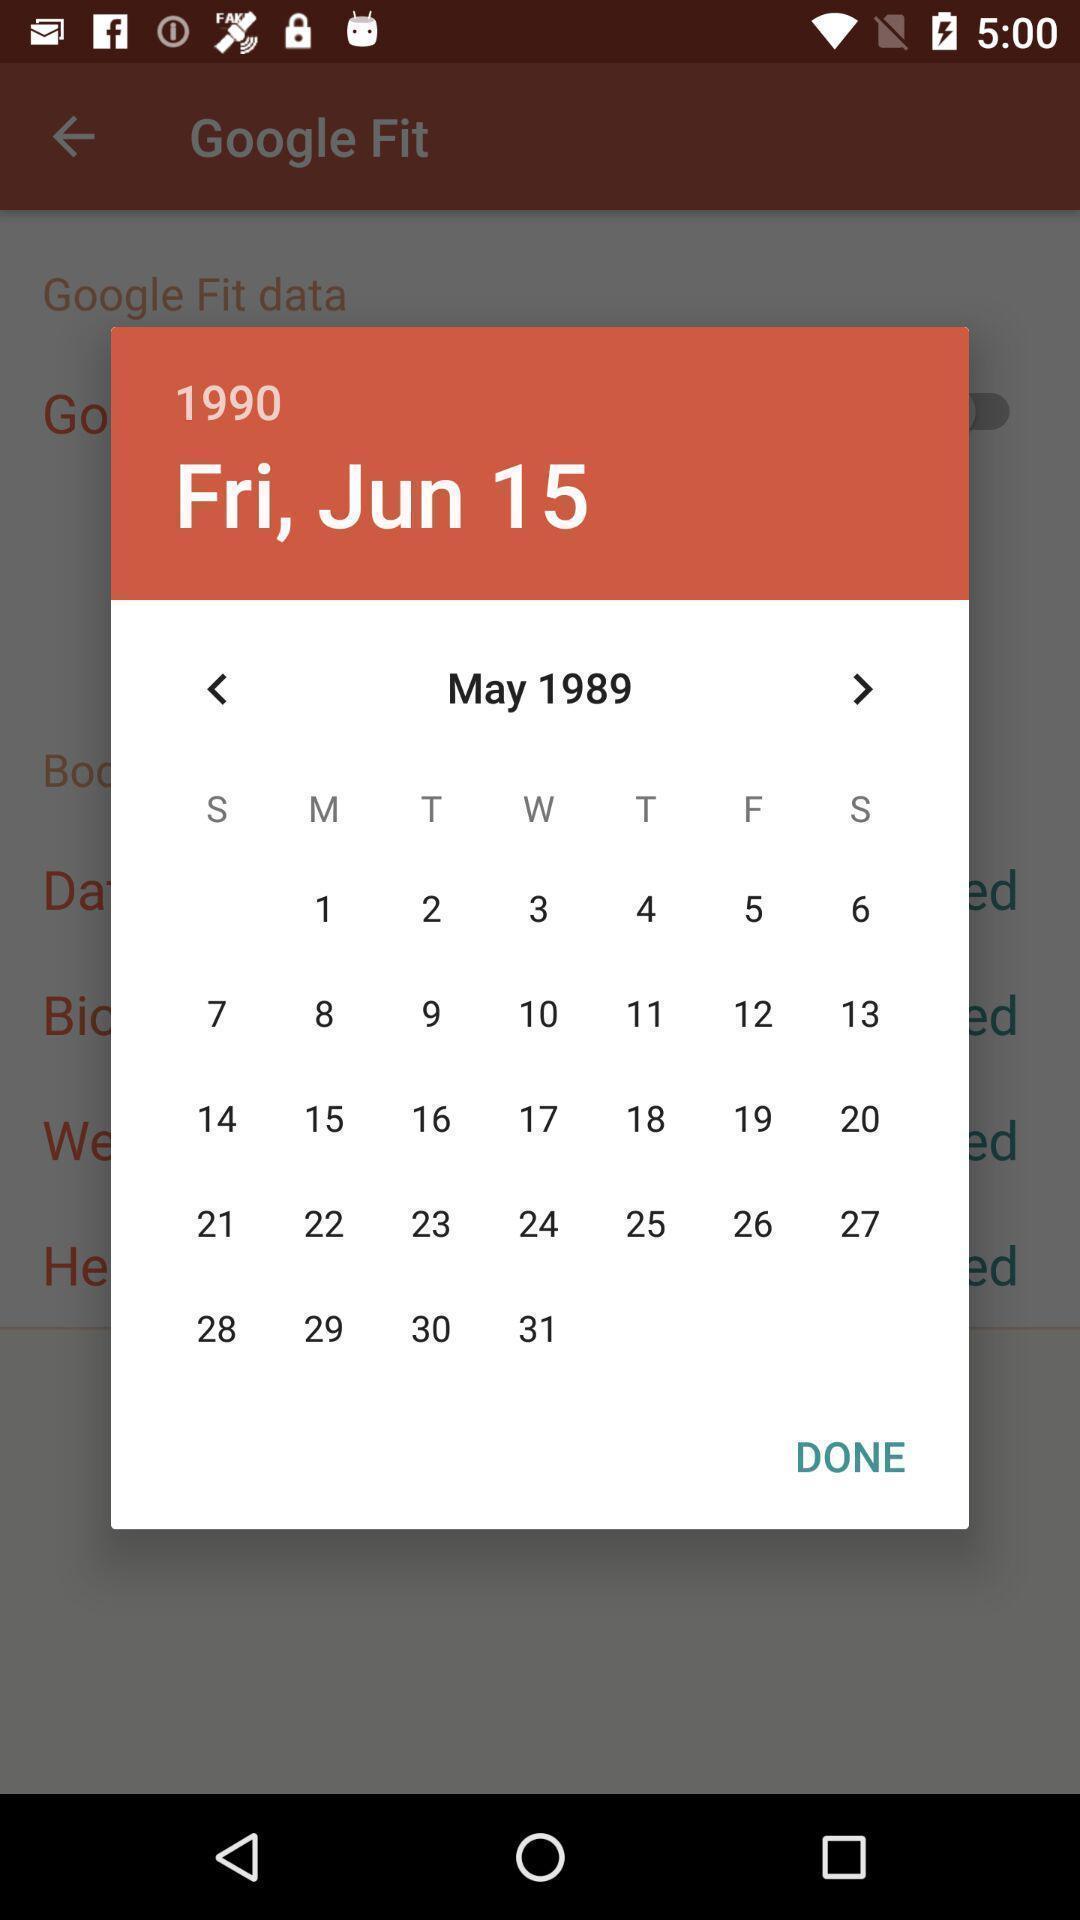Summarize the main components in this picture. Pop-up of a calendar to select date of birth. 